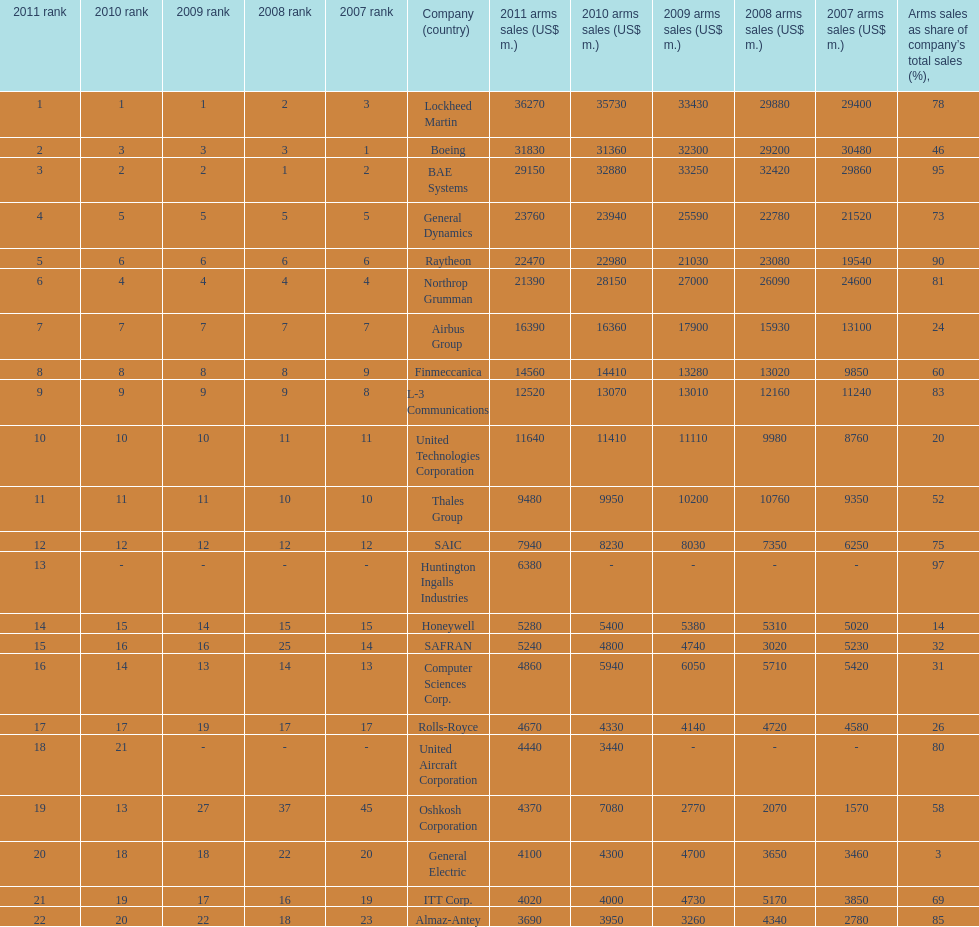Determine the variation between boeing's 2010 arms sales and raytheon's 2010 arms sales. 8380. 